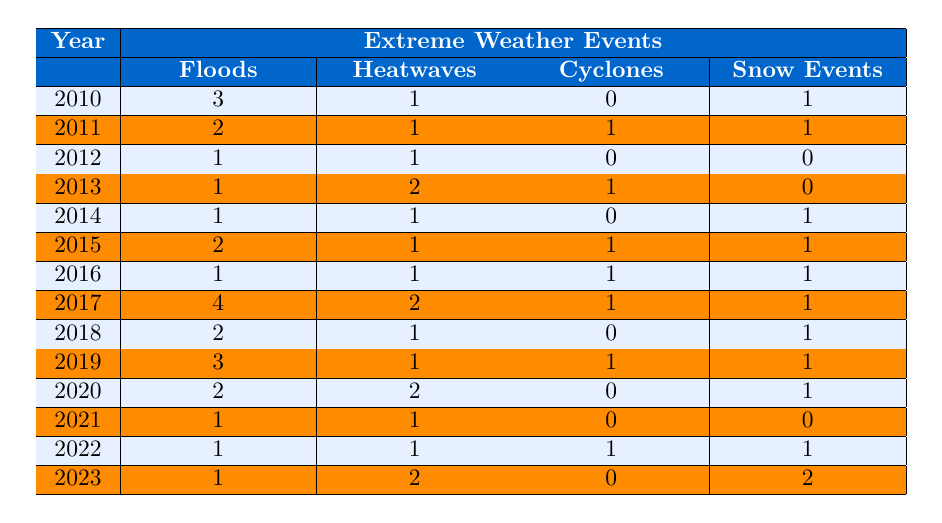What year had the highest number of floods? By examining the column for floods, the highest number of occurrences is 4, which happened in 2017.
Answer: 2017 How many total heatwaves occurred from 2010 to 2023? Adding the occurrences of heatwaves from each year: 1 + 1 + 1 + 2 + 1 + 1 + 1 + 2 + 1 + 1 + 2 + 1 + 1 + 2 = 16.
Answer: 16 Was there a year without any cyclones recorded? Reviewing the cyclones column, it shows that in the years 2010, 2012, 2014, 2015, 2018, 2020, 2021, and 2023, there were no occurrences. Thus, yes, there are multiple years without cyclones.
Answer: Yes In which year did both floods and heatwaves occur the most? Comparing the occurrences in each year, 2017 had the highest floods (4) and 2 heatwaves, making it the year with the highest combined events for both categories.
Answer: 2017 What is the average number of snow events per year from 2010 to 2023? The total occurrences of snow events (1 + 1 + 0 + 0 + 1 + 1 + 1 + 1 + 1 + 1 + 1 + 0 + 1 + 2 = 12), divided by the number of years (14), gives an average of 12/14 = approximately 0.857.
Answer: Approximately 0.857 Which type of extreme weather event was the least frequent in 2021? Looking at the occurrences for 2021, floods, heatwaves, and cyclones all had 1 occurrence, but the snow events had 0, which makes snow events the least frequent that year.
Answer: Snow events How many cyclones were recorded between 2010 and 2023? Summing the occurrences of cyclones from the table: 0 + 1 + 0 + 1 + 0 + 1 + 1 + 1 + 0 + 1 + 0 + 0 + 1 + 0 = 6.
Answer: 6 In which year did the total occurrences of all extreme weather events peak? Summing all event types for each year, the highest total occurs in 2017 with 4 floods, 2 heatwaves, 1 cyclone, and 1 snow event, totaling 8 events.
Answer: 2017 How many years had more than 2 occurrences of floods? Looking at the floods column, the years with more than 2 occurrences are 2010 (3) and 2017 (4), making a total of 2 years.
Answer: 2 years Which event type had the highest occurrence in 2013? In the year 2013, floods and heatwaves both occurred once, while cyclones occurred once, and snow events did not occur; therefore, there is a tie, but floods are notable due to the no snow event.
Answer: Tied: floods, heatwaves, and cyclones (1 occurrence each) 